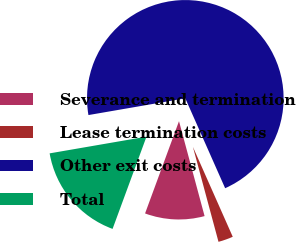Convert chart to OTSL. <chart><loc_0><loc_0><loc_500><loc_500><pie_chart><fcel>Severance and termination<fcel>Lease termination costs<fcel>Other exit costs<fcel>Total<nl><fcel>9.8%<fcel>2.45%<fcel>71.08%<fcel>16.67%<nl></chart> 